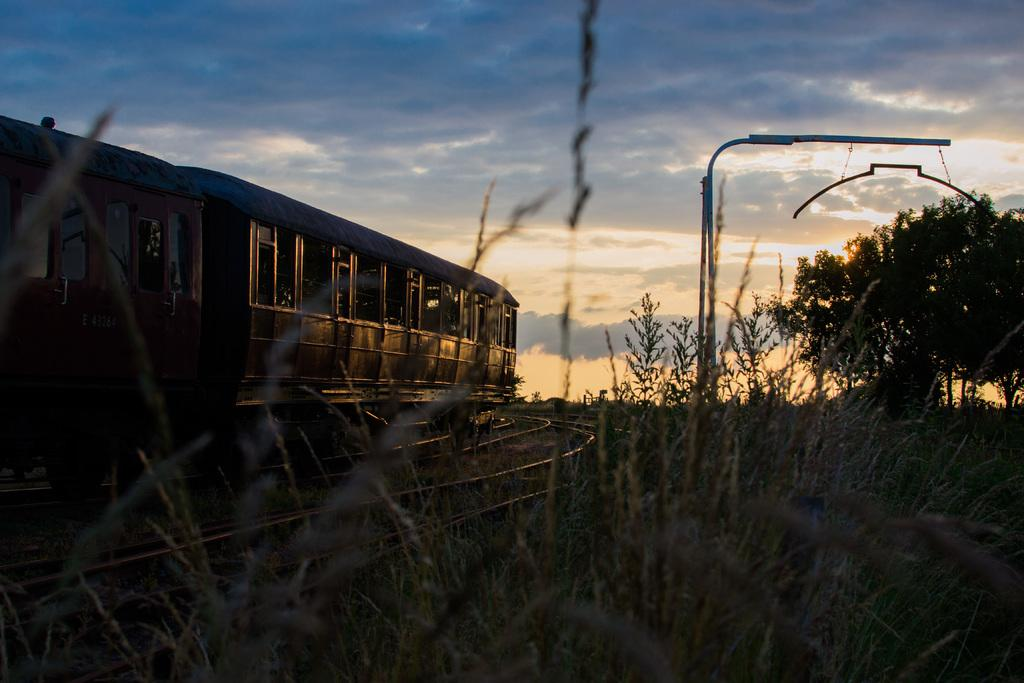What structure: What is located on the left side of the image? There is a train on the left side of the image. What can be seen on the right side of the image? There is a pole and trees on the right side of the image. What is visible at the top of the image? The sky is visible at the top of the image. Can you tell me how many lawyers are on the train in the image? There is no mention of lawyers or any legal professionals in the image; it features a train and other objects. Is there a boat visible in the image? No, there is no boat present in the image. 